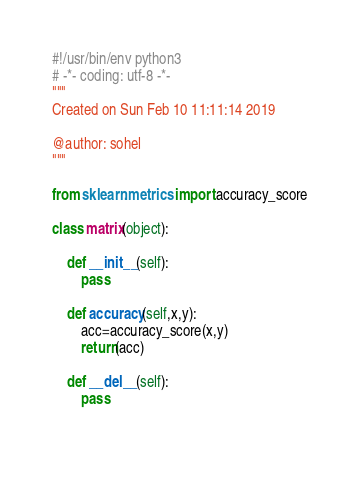<code> <loc_0><loc_0><loc_500><loc_500><_Python_>#!/usr/bin/env python3
# -*- coding: utf-8 -*-
"""
Created on Sun Feb 10 11:11:14 2019

@author: sohel
"""

from sklearn.metrics import accuracy_score

class matrix(object):
    
    def __init__(self):
        pass
    
    def accuracy(self,x,y):
        acc=accuracy_score(x,y)
        return(acc)
        
    def __del__(self):
        pass
    </code> 